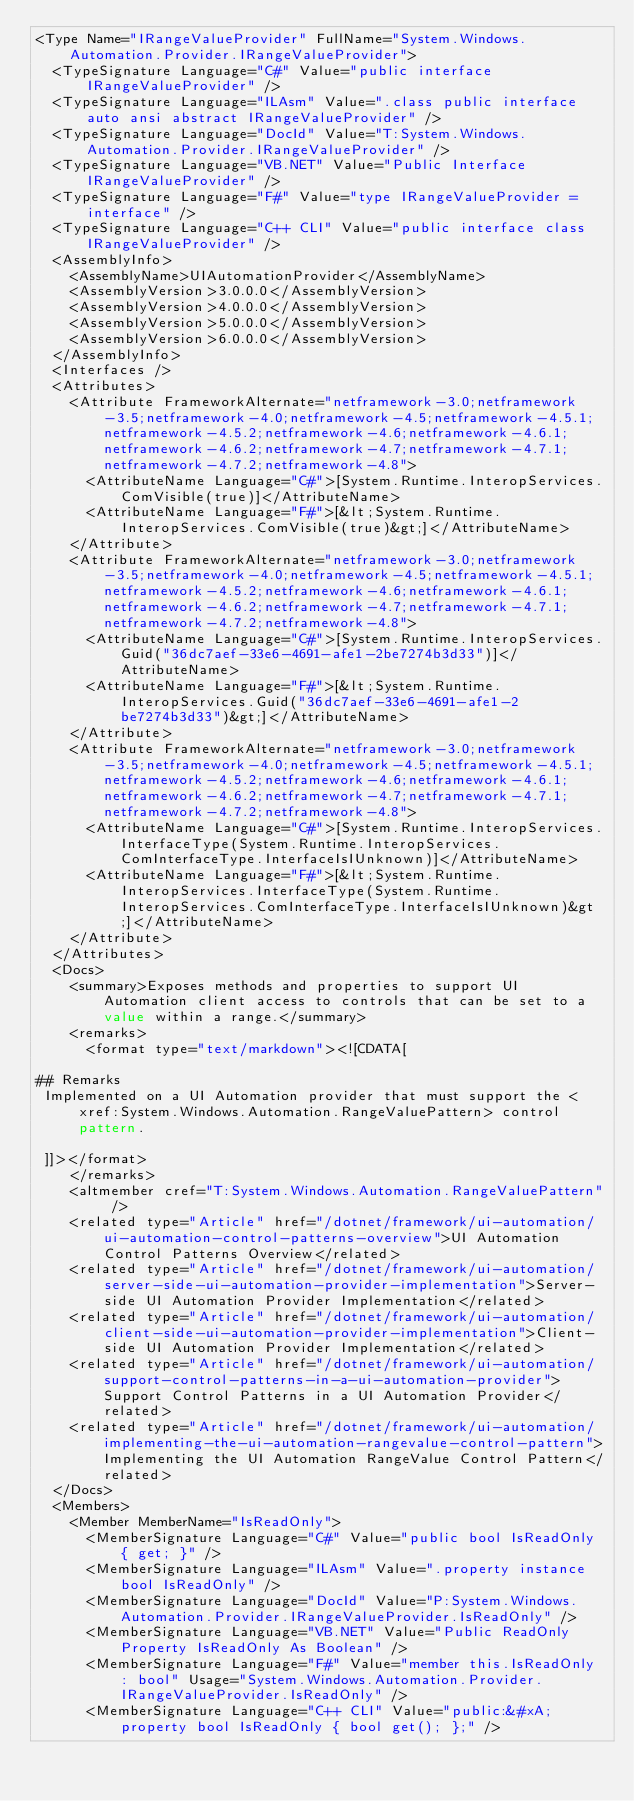<code> <loc_0><loc_0><loc_500><loc_500><_XML_><Type Name="IRangeValueProvider" FullName="System.Windows.Automation.Provider.IRangeValueProvider">
  <TypeSignature Language="C#" Value="public interface IRangeValueProvider" />
  <TypeSignature Language="ILAsm" Value=".class public interface auto ansi abstract IRangeValueProvider" />
  <TypeSignature Language="DocId" Value="T:System.Windows.Automation.Provider.IRangeValueProvider" />
  <TypeSignature Language="VB.NET" Value="Public Interface IRangeValueProvider" />
  <TypeSignature Language="F#" Value="type IRangeValueProvider = interface" />
  <TypeSignature Language="C++ CLI" Value="public interface class IRangeValueProvider" />
  <AssemblyInfo>
    <AssemblyName>UIAutomationProvider</AssemblyName>
    <AssemblyVersion>3.0.0.0</AssemblyVersion>
    <AssemblyVersion>4.0.0.0</AssemblyVersion>
    <AssemblyVersion>5.0.0.0</AssemblyVersion>
    <AssemblyVersion>6.0.0.0</AssemblyVersion>
  </AssemblyInfo>
  <Interfaces />
  <Attributes>
    <Attribute FrameworkAlternate="netframework-3.0;netframework-3.5;netframework-4.0;netframework-4.5;netframework-4.5.1;netframework-4.5.2;netframework-4.6;netframework-4.6.1;netframework-4.6.2;netframework-4.7;netframework-4.7.1;netframework-4.7.2;netframework-4.8">
      <AttributeName Language="C#">[System.Runtime.InteropServices.ComVisible(true)]</AttributeName>
      <AttributeName Language="F#">[&lt;System.Runtime.InteropServices.ComVisible(true)&gt;]</AttributeName>
    </Attribute>
    <Attribute FrameworkAlternate="netframework-3.0;netframework-3.5;netframework-4.0;netframework-4.5;netframework-4.5.1;netframework-4.5.2;netframework-4.6;netframework-4.6.1;netframework-4.6.2;netframework-4.7;netframework-4.7.1;netframework-4.7.2;netframework-4.8">
      <AttributeName Language="C#">[System.Runtime.InteropServices.Guid("36dc7aef-33e6-4691-afe1-2be7274b3d33")]</AttributeName>
      <AttributeName Language="F#">[&lt;System.Runtime.InteropServices.Guid("36dc7aef-33e6-4691-afe1-2be7274b3d33")&gt;]</AttributeName>
    </Attribute>
    <Attribute FrameworkAlternate="netframework-3.0;netframework-3.5;netframework-4.0;netframework-4.5;netframework-4.5.1;netframework-4.5.2;netframework-4.6;netframework-4.6.1;netframework-4.6.2;netframework-4.7;netframework-4.7.1;netframework-4.7.2;netframework-4.8">
      <AttributeName Language="C#">[System.Runtime.InteropServices.InterfaceType(System.Runtime.InteropServices.ComInterfaceType.InterfaceIsIUnknown)]</AttributeName>
      <AttributeName Language="F#">[&lt;System.Runtime.InteropServices.InterfaceType(System.Runtime.InteropServices.ComInterfaceType.InterfaceIsIUnknown)&gt;]</AttributeName>
    </Attribute>
  </Attributes>
  <Docs>
    <summary>Exposes methods and properties to support UI Automation client access to controls that can be set to a value within a range.</summary>
    <remarks>
      <format type="text/markdown"><![CDATA[  
  
## Remarks  
 Implemented on a UI Automation provider that must support the <xref:System.Windows.Automation.RangeValuePattern> control pattern.  
  
 ]]></format>
    </remarks>
    <altmember cref="T:System.Windows.Automation.RangeValuePattern" />
    <related type="Article" href="/dotnet/framework/ui-automation/ui-automation-control-patterns-overview">UI Automation Control Patterns Overview</related>
    <related type="Article" href="/dotnet/framework/ui-automation/server-side-ui-automation-provider-implementation">Server-side UI Automation Provider Implementation</related>
    <related type="Article" href="/dotnet/framework/ui-automation/client-side-ui-automation-provider-implementation">Client-side UI Automation Provider Implementation</related>
    <related type="Article" href="/dotnet/framework/ui-automation/support-control-patterns-in-a-ui-automation-provider">Support Control Patterns in a UI Automation Provider</related>
    <related type="Article" href="/dotnet/framework/ui-automation/implementing-the-ui-automation-rangevalue-control-pattern">Implementing the UI Automation RangeValue Control Pattern</related>
  </Docs>
  <Members>
    <Member MemberName="IsReadOnly">
      <MemberSignature Language="C#" Value="public bool IsReadOnly { get; }" />
      <MemberSignature Language="ILAsm" Value=".property instance bool IsReadOnly" />
      <MemberSignature Language="DocId" Value="P:System.Windows.Automation.Provider.IRangeValueProvider.IsReadOnly" />
      <MemberSignature Language="VB.NET" Value="Public ReadOnly Property IsReadOnly As Boolean" />
      <MemberSignature Language="F#" Value="member this.IsReadOnly : bool" Usage="System.Windows.Automation.Provider.IRangeValueProvider.IsReadOnly" />
      <MemberSignature Language="C++ CLI" Value="public:&#xA; property bool IsReadOnly { bool get(); };" /></code> 